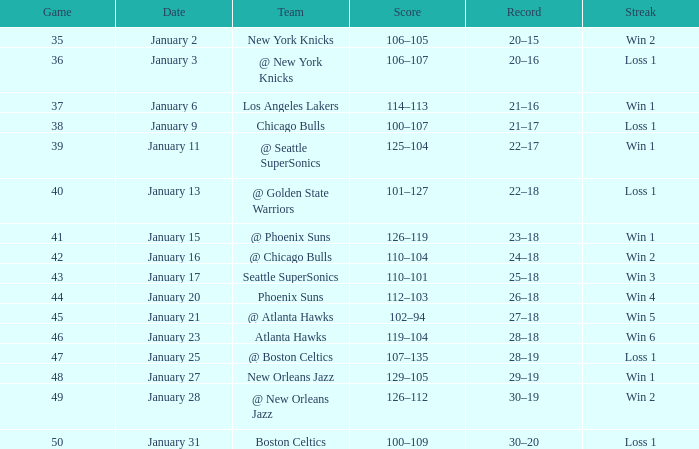What is the Team in Game 38? Chicago Bulls. 